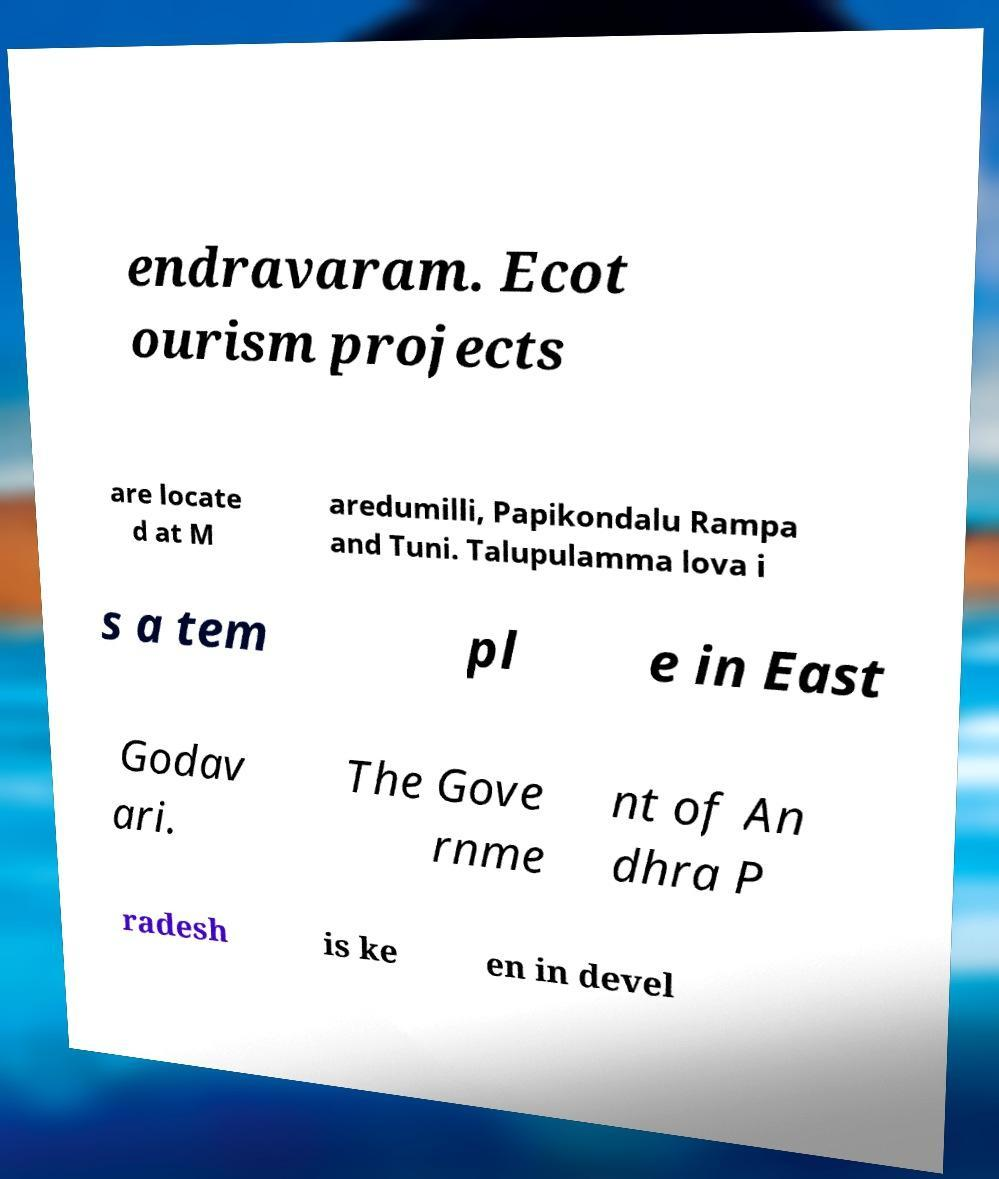What messages or text are displayed in this image? I need them in a readable, typed format. endravaram. Ecot ourism projects are locate d at M aredumilli, Papikondalu Rampa and Tuni. Talupulamma lova i s a tem pl e in East Godav ari. The Gove rnme nt of An dhra P radesh is ke en in devel 